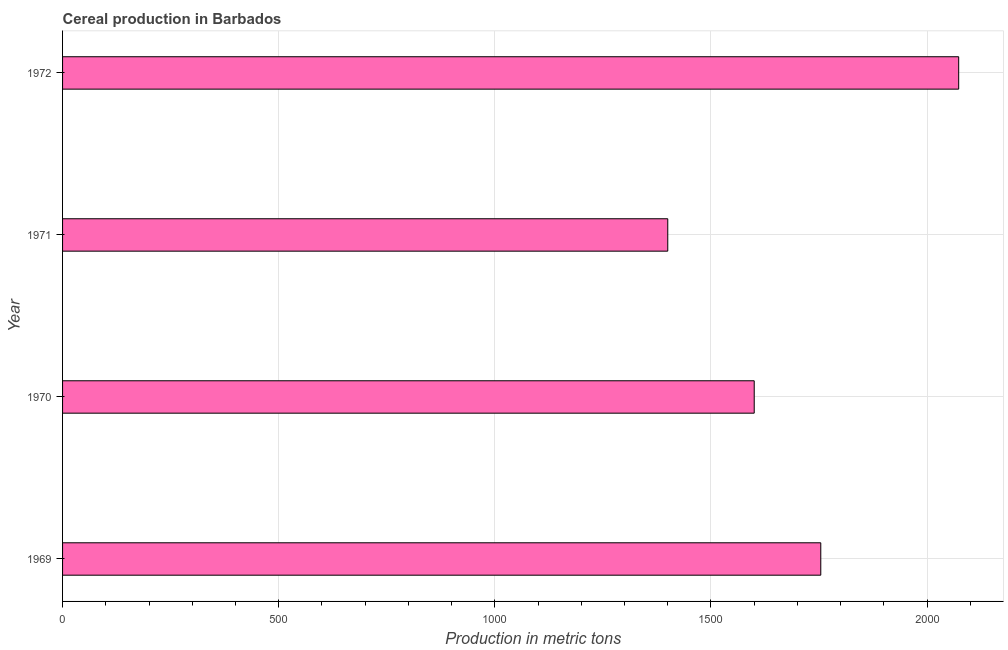Does the graph contain grids?
Ensure brevity in your answer.  Yes. What is the title of the graph?
Keep it short and to the point. Cereal production in Barbados. What is the label or title of the X-axis?
Your answer should be very brief. Production in metric tons. What is the label or title of the Y-axis?
Offer a very short reply. Year. What is the cereal production in 1969?
Offer a terse response. 1754. Across all years, what is the maximum cereal production?
Provide a short and direct response. 2073. Across all years, what is the minimum cereal production?
Your response must be concise. 1400. In which year was the cereal production minimum?
Your response must be concise. 1971. What is the sum of the cereal production?
Give a very brief answer. 6827. What is the difference between the cereal production in 1969 and 1970?
Offer a very short reply. 154. What is the average cereal production per year?
Offer a very short reply. 1706. What is the median cereal production?
Your answer should be very brief. 1677. Do a majority of the years between 1972 and 1970 (inclusive) have cereal production greater than 300 metric tons?
Offer a terse response. Yes. What is the ratio of the cereal production in 1969 to that in 1971?
Give a very brief answer. 1.25. Is the difference between the cereal production in 1969 and 1972 greater than the difference between any two years?
Offer a terse response. No. What is the difference between the highest and the second highest cereal production?
Keep it short and to the point. 319. Is the sum of the cereal production in 1971 and 1972 greater than the maximum cereal production across all years?
Make the answer very short. Yes. What is the difference between the highest and the lowest cereal production?
Provide a short and direct response. 673. In how many years, is the cereal production greater than the average cereal production taken over all years?
Provide a succinct answer. 2. How many bars are there?
Offer a very short reply. 4. Are all the bars in the graph horizontal?
Your response must be concise. Yes. What is the difference between two consecutive major ticks on the X-axis?
Keep it short and to the point. 500. What is the Production in metric tons in 1969?
Your answer should be compact. 1754. What is the Production in metric tons in 1970?
Keep it short and to the point. 1600. What is the Production in metric tons of 1971?
Give a very brief answer. 1400. What is the Production in metric tons in 1972?
Provide a succinct answer. 2073. What is the difference between the Production in metric tons in 1969 and 1970?
Offer a very short reply. 154. What is the difference between the Production in metric tons in 1969 and 1971?
Offer a terse response. 354. What is the difference between the Production in metric tons in 1969 and 1972?
Make the answer very short. -319. What is the difference between the Production in metric tons in 1970 and 1971?
Your answer should be very brief. 200. What is the difference between the Production in metric tons in 1970 and 1972?
Ensure brevity in your answer.  -473. What is the difference between the Production in metric tons in 1971 and 1972?
Your answer should be compact. -673. What is the ratio of the Production in metric tons in 1969 to that in 1970?
Offer a very short reply. 1.1. What is the ratio of the Production in metric tons in 1969 to that in 1971?
Make the answer very short. 1.25. What is the ratio of the Production in metric tons in 1969 to that in 1972?
Your response must be concise. 0.85. What is the ratio of the Production in metric tons in 1970 to that in 1971?
Your answer should be very brief. 1.14. What is the ratio of the Production in metric tons in 1970 to that in 1972?
Offer a terse response. 0.77. What is the ratio of the Production in metric tons in 1971 to that in 1972?
Provide a succinct answer. 0.68. 